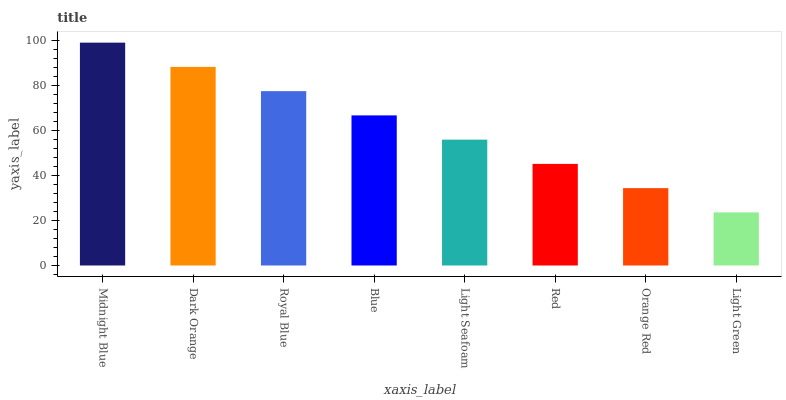Is Light Green the minimum?
Answer yes or no. Yes. Is Midnight Blue the maximum?
Answer yes or no. Yes. Is Dark Orange the minimum?
Answer yes or no. No. Is Dark Orange the maximum?
Answer yes or no. No. Is Midnight Blue greater than Dark Orange?
Answer yes or no. Yes. Is Dark Orange less than Midnight Blue?
Answer yes or no. Yes. Is Dark Orange greater than Midnight Blue?
Answer yes or no. No. Is Midnight Blue less than Dark Orange?
Answer yes or no. No. Is Blue the high median?
Answer yes or no. Yes. Is Light Seafoam the low median?
Answer yes or no. Yes. Is Light Green the high median?
Answer yes or no. No. Is Dark Orange the low median?
Answer yes or no. No. 